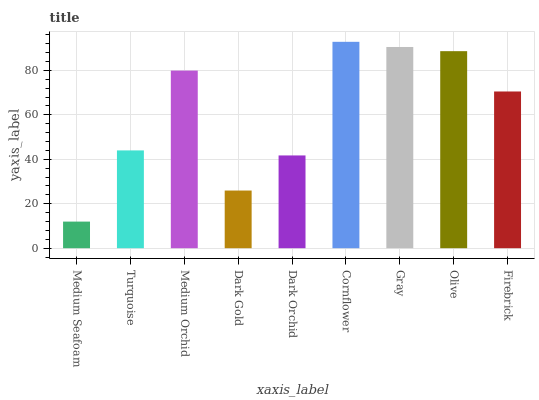Is Medium Seafoam the minimum?
Answer yes or no. Yes. Is Cornflower the maximum?
Answer yes or no. Yes. Is Turquoise the minimum?
Answer yes or no. No. Is Turquoise the maximum?
Answer yes or no. No. Is Turquoise greater than Medium Seafoam?
Answer yes or no. Yes. Is Medium Seafoam less than Turquoise?
Answer yes or no. Yes. Is Medium Seafoam greater than Turquoise?
Answer yes or no. No. Is Turquoise less than Medium Seafoam?
Answer yes or no. No. Is Firebrick the high median?
Answer yes or no. Yes. Is Firebrick the low median?
Answer yes or no. Yes. Is Dark Orchid the high median?
Answer yes or no. No. Is Dark Gold the low median?
Answer yes or no. No. 